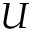Convert formula to latex. <formula><loc_0><loc_0><loc_500><loc_500>U</formula> 